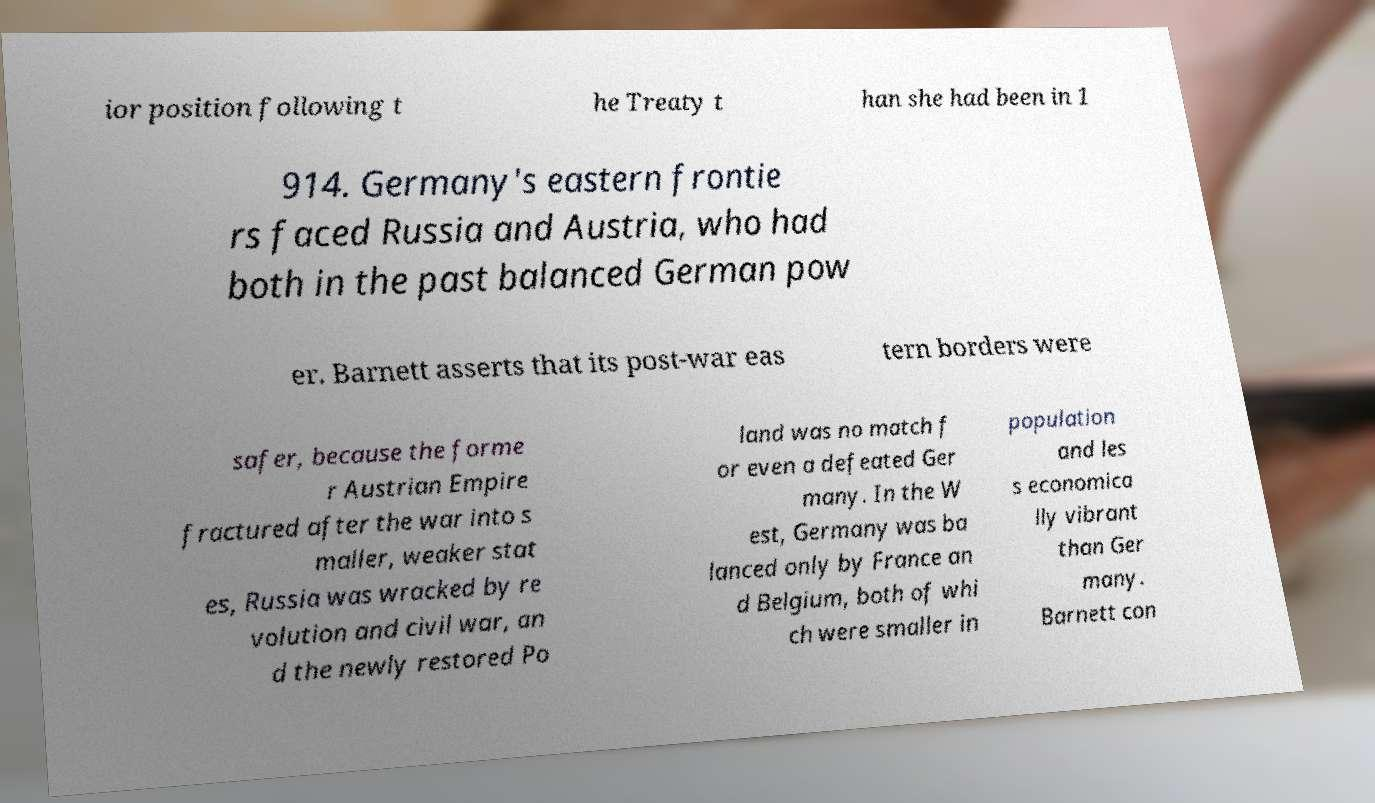There's text embedded in this image that I need extracted. Can you transcribe it verbatim? ior position following t he Treaty t han she had been in 1 914. Germany's eastern frontie rs faced Russia and Austria, who had both in the past balanced German pow er. Barnett asserts that its post-war eas tern borders were safer, because the forme r Austrian Empire fractured after the war into s maller, weaker stat es, Russia was wracked by re volution and civil war, an d the newly restored Po land was no match f or even a defeated Ger many. In the W est, Germany was ba lanced only by France an d Belgium, both of whi ch were smaller in population and les s economica lly vibrant than Ger many. Barnett con 